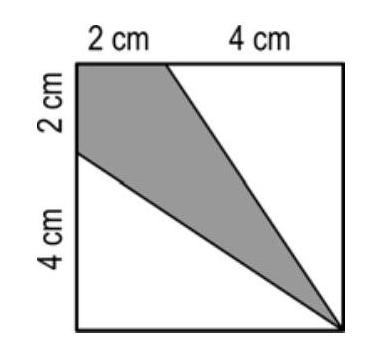What fraction of the square is grey?
Choices: ['$\\frac{1}{3}$', '$\\frac{1}{4}$', '$\\frac{1}{5}$', '$\\frac{3}{8}$', '$\\frac{2}{9}$'] Answer is A. 